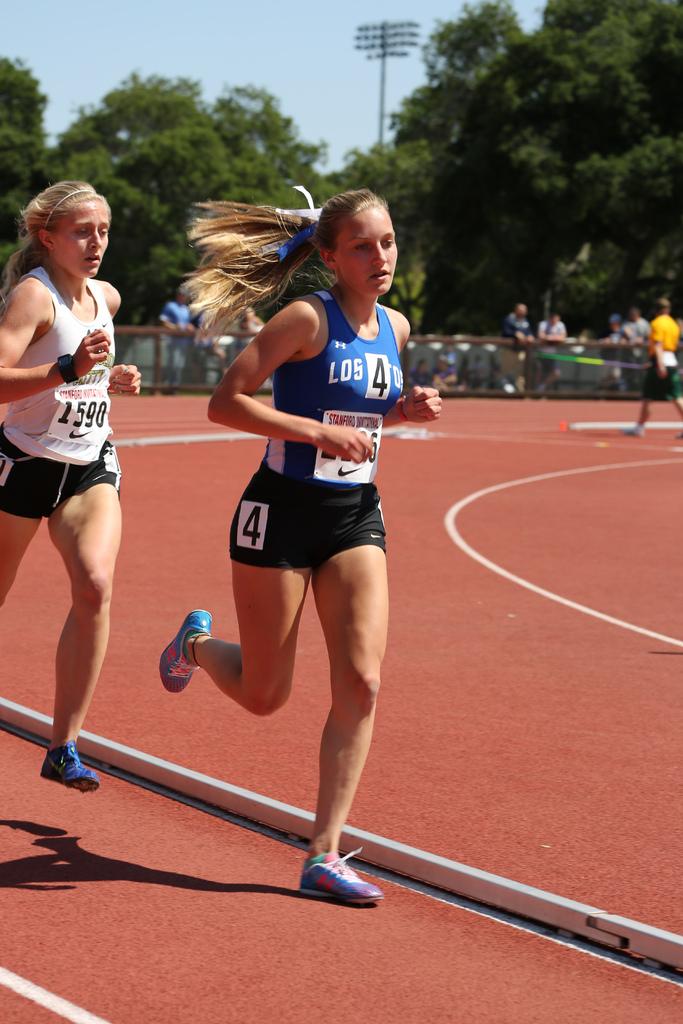What number is the runner in white?
Provide a short and direct response. 1590. 